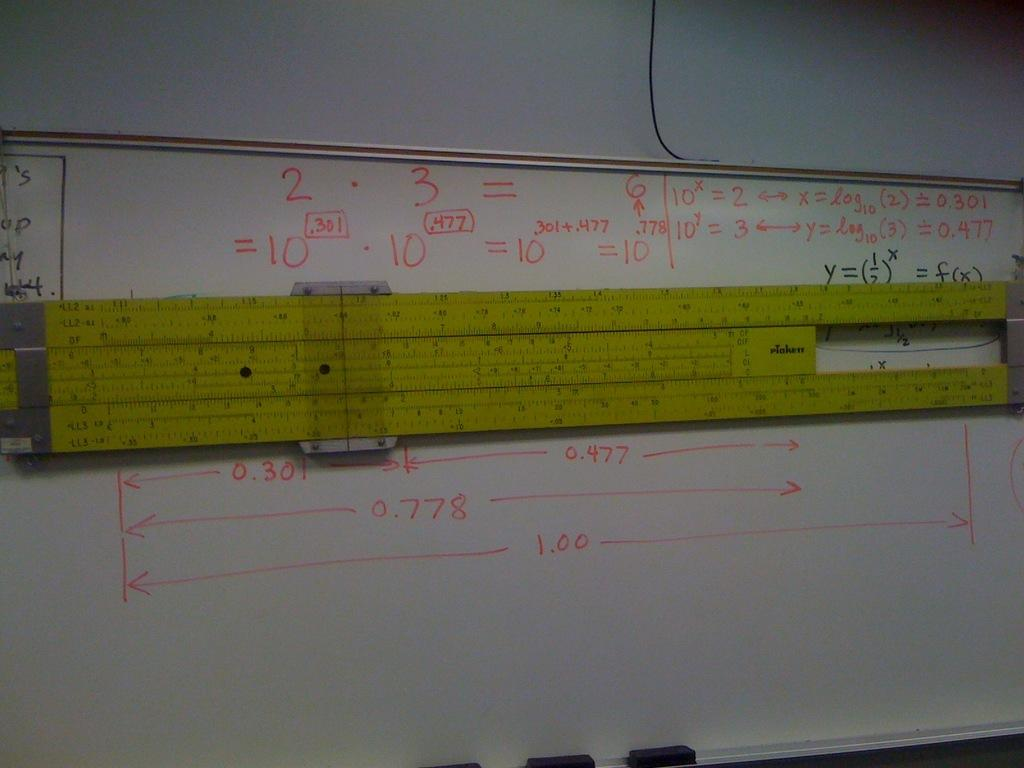<image>
Relay a brief, clear account of the picture shown. A big yellow slide ruler is shown on a white board with one calculation of 0.778. 